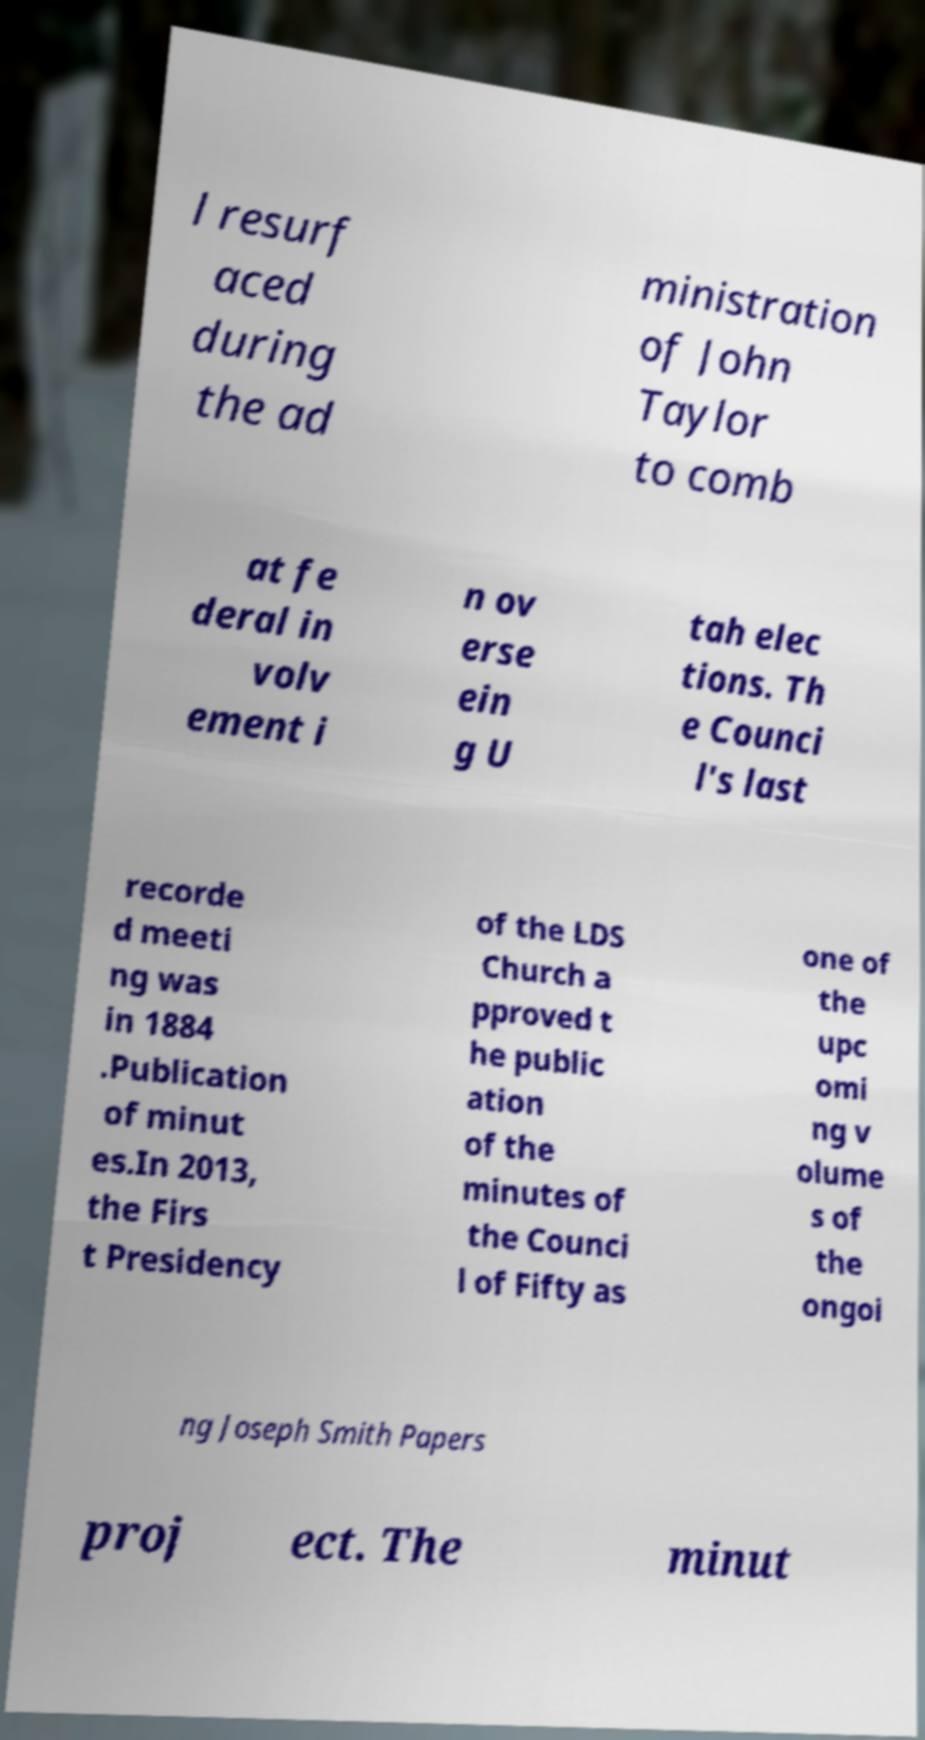There's text embedded in this image that I need extracted. Can you transcribe it verbatim? l resurf aced during the ad ministration of John Taylor to comb at fe deral in volv ement i n ov erse ein g U tah elec tions. Th e Counci l's last recorde d meeti ng was in 1884 .Publication of minut es.In 2013, the Firs t Presidency of the LDS Church a pproved t he public ation of the minutes of the Counci l of Fifty as one of the upc omi ng v olume s of the ongoi ng Joseph Smith Papers proj ect. The minut 